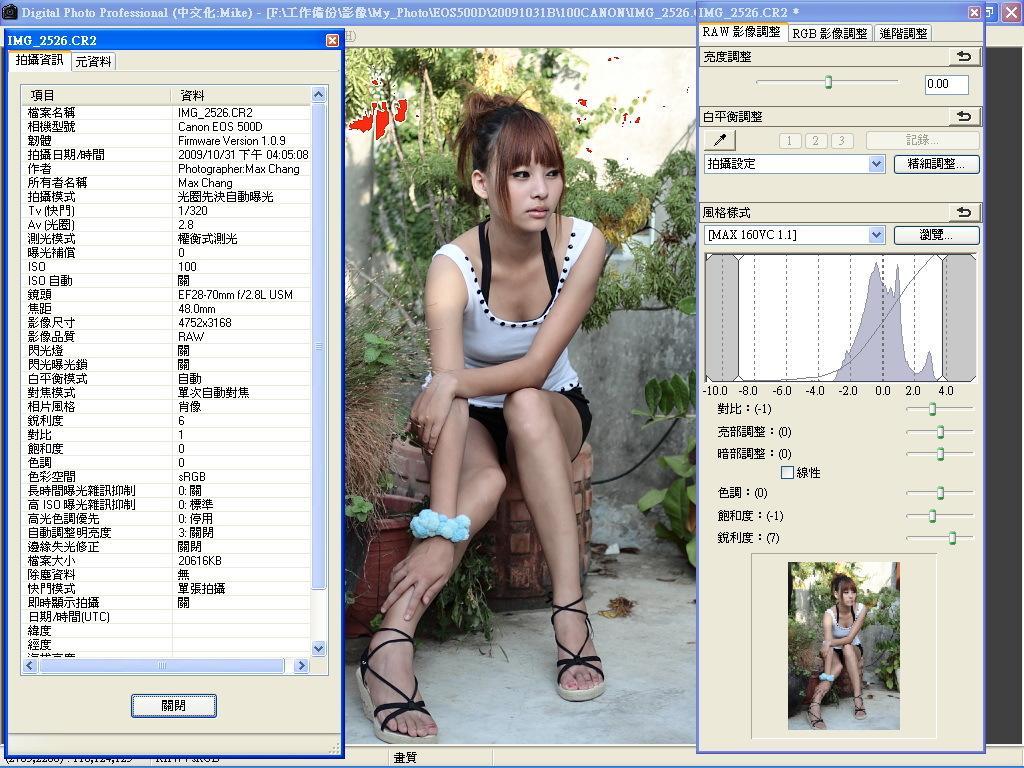Please provide a concise description of this image. In this image there is a screen shot of a monitor with an image of a girl and some text. 